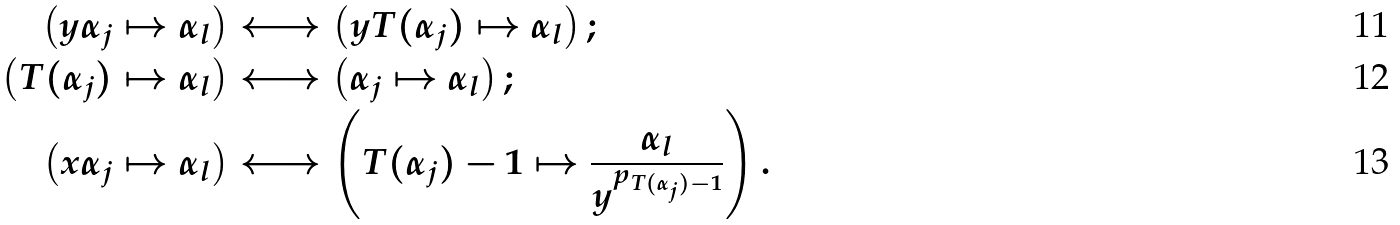<formula> <loc_0><loc_0><loc_500><loc_500>\left ( y \alpha _ { j } \mapsto \alpha _ { l } \right ) & \longleftrightarrow \left ( y T ( \alpha _ { j } ) \mapsto \alpha _ { l } \right ) ; \\ \left ( T ( \alpha _ { j } ) \mapsto \alpha _ { l } \right ) & \longleftrightarrow \left ( \alpha _ { j } \mapsto \alpha _ { l } \right ) ; \\ \left ( x \alpha _ { j } \mapsto \alpha _ { l } \right ) & \longleftrightarrow \left ( T ( \alpha _ { j } ) - 1 \mapsto \frac { \alpha _ { l } } { y ^ { p _ { T ( \alpha _ { j } ) - 1 } } } \right ) .</formula> 